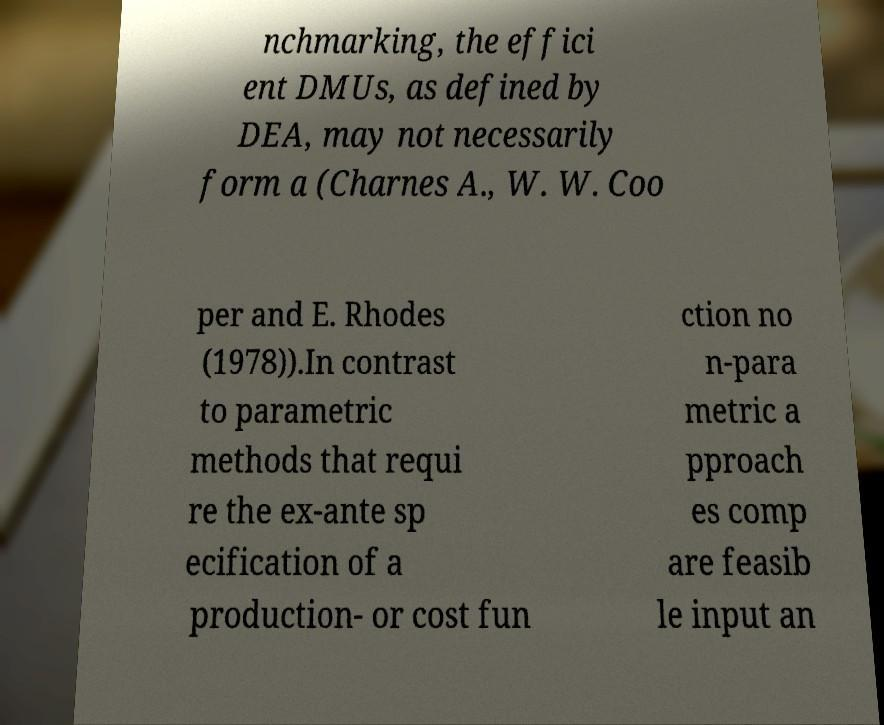Could you extract and type out the text from this image? nchmarking, the effici ent DMUs, as defined by DEA, may not necessarily form a (Charnes A., W. W. Coo per and E. Rhodes (1978)).In contrast to parametric methods that requi re the ex-ante sp ecification of a production- or cost fun ction no n-para metric a pproach es comp are feasib le input an 